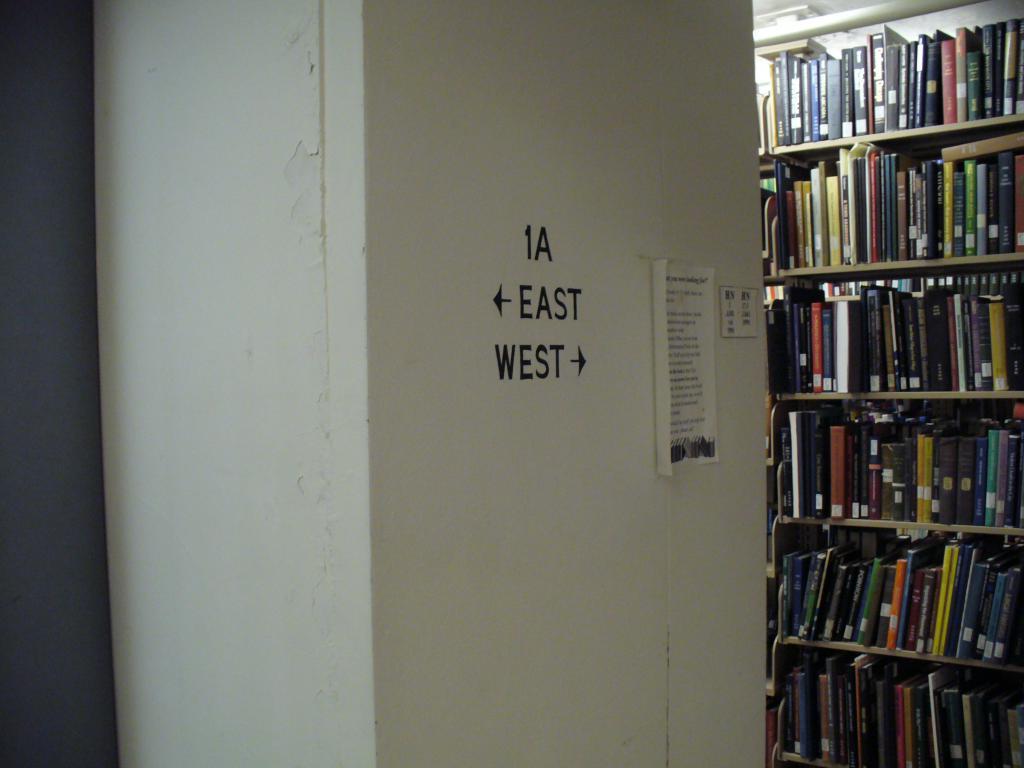Which way is left?
Provide a short and direct response. East. 